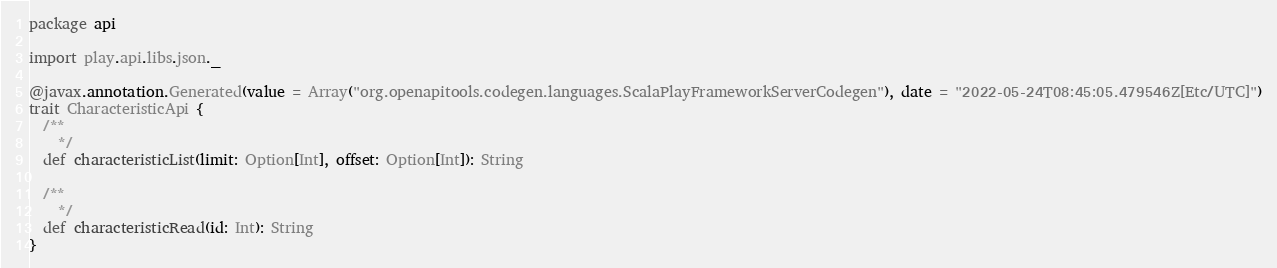<code> <loc_0><loc_0><loc_500><loc_500><_Scala_>package api

import play.api.libs.json._

@javax.annotation.Generated(value = Array("org.openapitools.codegen.languages.ScalaPlayFrameworkServerCodegen"), date = "2022-05-24T08:45:05.479546Z[Etc/UTC]")
trait CharacteristicApi {
  /**
    */
  def characteristicList(limit: Option[Int], offset: Option[Int]): String

  /**
    */
  def characteristicRead(id: Int): String
}
</code> 